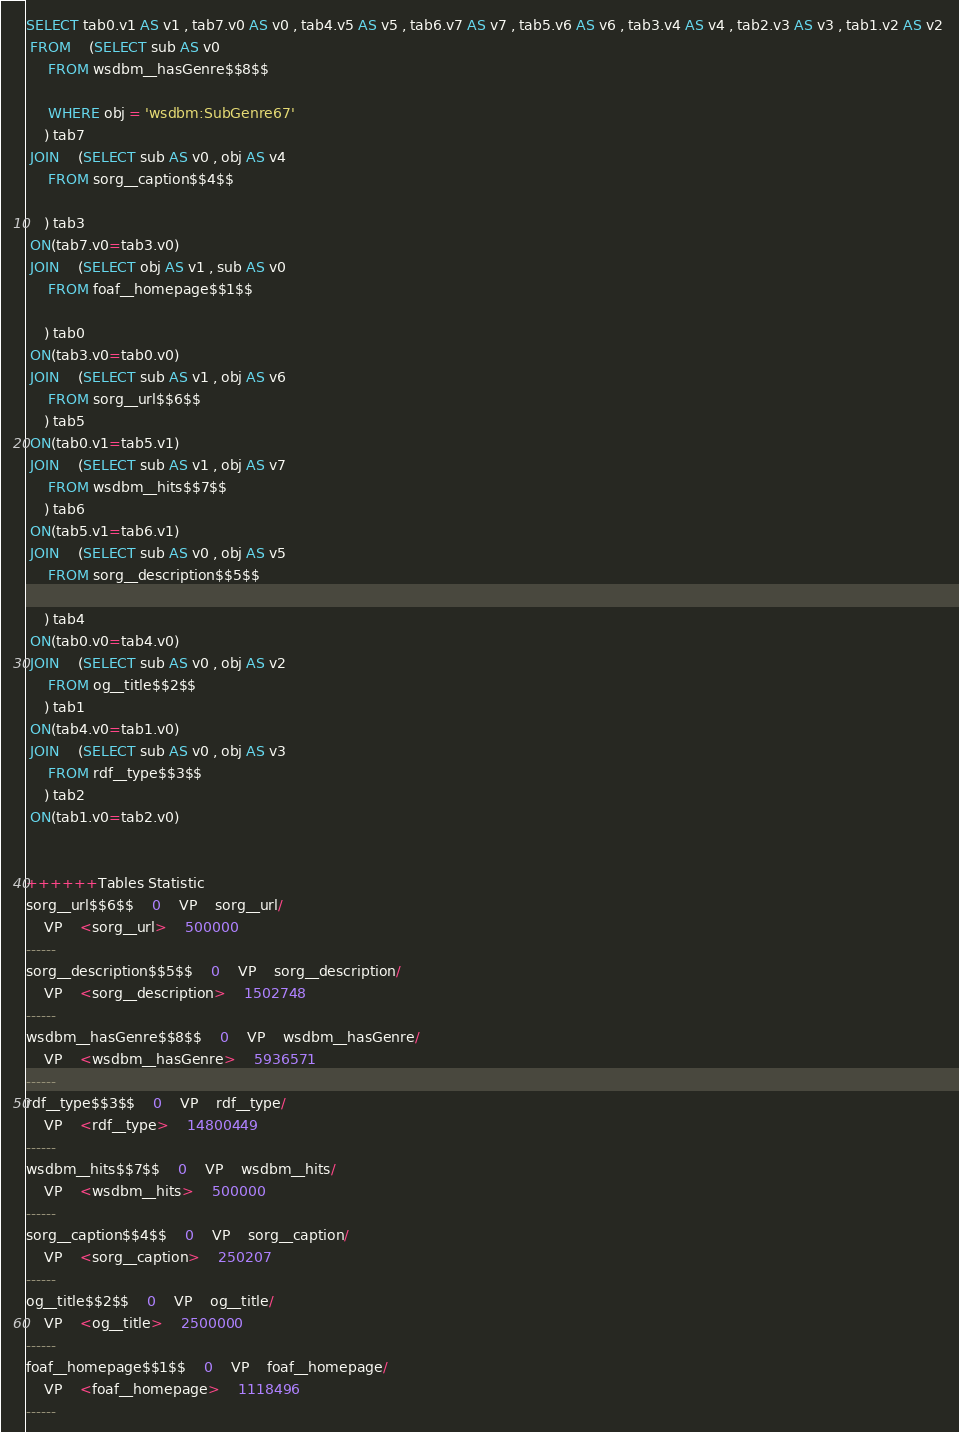Convert code to text. <code><loc_0><loc_0><loc_500><loc_500><_SQL_>SELECT tab0.v1 AS v1 , tab7.v0 AS v0 , tab4.v5 AS v5 , tab6.v7 AS v7 , tab5.v6 AS v6 , tab3.v4 AS v4 , tab2.v3 AS v3 , tab1.v2 AS v2 
 FROM    (SELECT sub AS v0 
	 FROM wsdbm__hasGenre$$8$$
	 
	 WHERE obj = 'wsdbm:SubGenre67'
	) tab7
 JOIN    (SELECT sub AS v0 , obj AS v4 
	 FROM sorg__caption$$4$$
	
	) tab3
 ON(tab7.v0=tab3.v0)
 JOIN    (SELECT obj AS v1 , sub AS v0 
	 FROM foaf__homepage$$1$$
	
	) tab0
 ON(tab3.v0=tab0.v0)
 JOIN    (SELECT sub AS v1 , obj AS v6 
	 FROM sorg__url$$6$$
	) tab5
 ON(tab0.v1=tab5.v1)
 JOIN    (SELECT sub AS v1 , obj AS v7 
	 FROM wsdbm__hits$$7$$
	) tab6
 ON(tab5.v1=tab6.v1)
 JOIN    (SELECT sub AS v0 , obj AS v5 
	 FROM sorg__description$$5$$
	
	) tab4
 ON(tab0.v0=tab4.v0)
 JOIN    (SELECT sub AS v0 , obj AS v2 
	 FROM og__title$$2$$
	) tab1
 ON(tab4.v0=tab1.v0)
 JOIN    (SELECT sub AS v0 , obj AS v3 
	 FROM rdf__type$$3$$
	) tab2
 ON(tab1.v0=tab2.v0)


++++++Tables Statistic
sorg__url$$6$$	0	VP	sorg__url/
	VP	<sorg__url>	500000
------
sorg__description$$5$$	0	VP	sorg__description/
	VP	<sorg__description>	1502748
------
wsdbm__hasGenre$$8$$	0	VP	wsdbm__hasGenre/
	VP	<wsdbm__hasGenre>	5936571
------
rdf__type$$3$$	0	VP	rdf__type/
	VP	<rdf__type>	14800449
------
wsdbm__hits$$7$$	0	VP	wsdbm__hits/
	VP	<wsdbm__hits>	500000
------
sorg__caption$$4$$	0	VP	sorg__caption/
	VP	<sorg__caption>	250207
------
og__title$$2$$	0	VP	og__title/
	VP	<og__title>	2500000
------
foaf__homepage$$1$$	0	VP	foaf__homepage/
	VP	<foaf__homepage>	1118496
------
</code> 